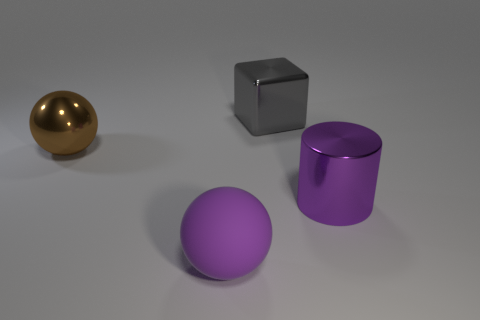Add 2 big purple objects. How many objects exist? 6 Subtract all blocks. How many objects are left? 3 Add 3 big brown cubes. How many big brown cubes exist? 3 Subtract 0 green balls. How many objects are left? 4 Subtract all big purple metal objects. Subtract all tiny cyan metallic cylinders. How many objects are left? 3 Add 1 large purple metal things. How many large purple metal things are left? 2 